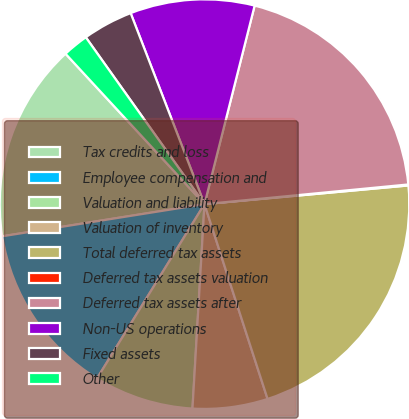<chart> <loc_0><loc_0><loc_500><loc_500><pie_chart><fcel>Tax credits and loss<fcel>Employee compensation and<fcel>Valuation and liability<fcel>Valuation of inventory<fcel>Total deferred tax assets<fcel>Deferred tax assets valuation<fcel>Deferred tax assets after<fcel>Non-US operations<fcel>Fixed assets<fcel>Other<nl><fcel>15.64%<fcel>13.7%<fcel>7.86%<fcel>5.92%<fcel>21.47%<fcel>0.08%<fcel>19.53%<fcel>9.81%<fcel>3.97%<fcel>2.03%<nl></chart> 